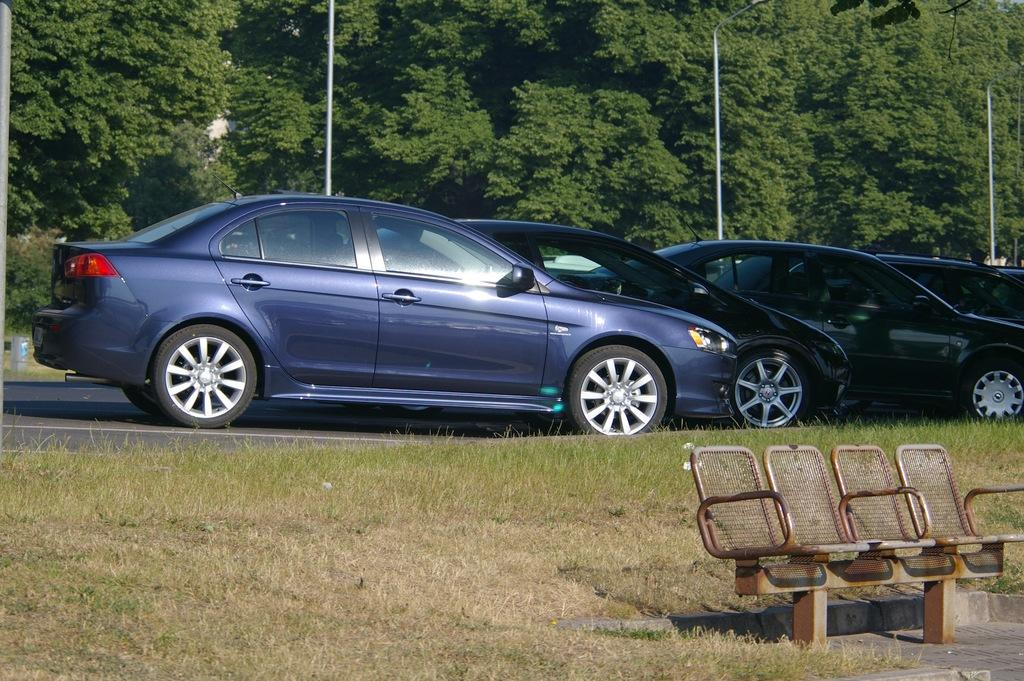What type of seating is visible in the image? There is a bench in the image. What type of ground surface is at the bottom of the image? There is grass at the bottom of the image. What type of vehicles can be seen on the road in the image? There are cars on the road in the image. What type of vegetation is visible in the background of the image? There are trees in the background of the image. What type of structures are visible in the background of the image? There are poles in the background of the image. What type of underwear is hanging on the pole in the image? There is no underwear present in the image; only trees and poles are visible in the background. 